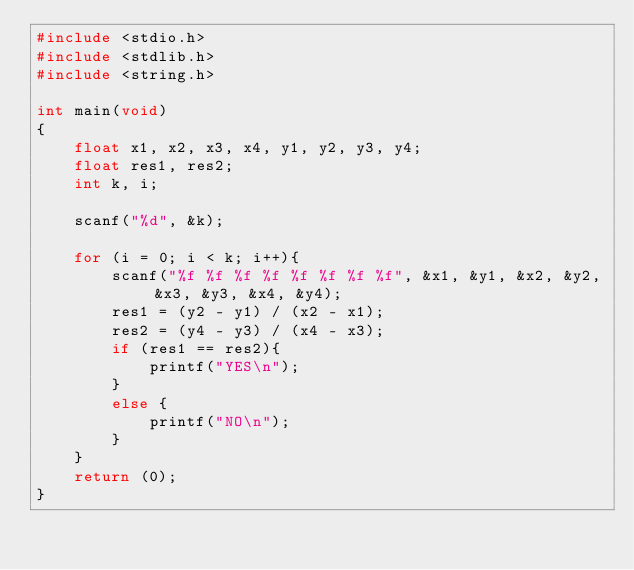<code> <loc_0><loc_0><loc_500><loc_500><_C_>#include <stdio.h>
#include <stdlib.h>
#include <string.h>

int main(void)
{
    float x1, x2, x3, x4, y1, y2, y3, y4;
    float res1, res2;
    int k, i;

    scanf("%d", &k);

    for (i = 0; i < k; i++){
        scanf("%f %f %f %f %f %f %f %f", &x1, &y1, &x2, &y2, &x3, &y3, &x4, &y4);
        res1 = (y2 - y1) / (x2 - x1);
        res2 = (y4 - y3) / (x4 - x3);
        if (res1 == res2){
            printf("YES\n");
        }
        else {
            printf("NO\n");
        }
    }
    return (0);
}</code> 